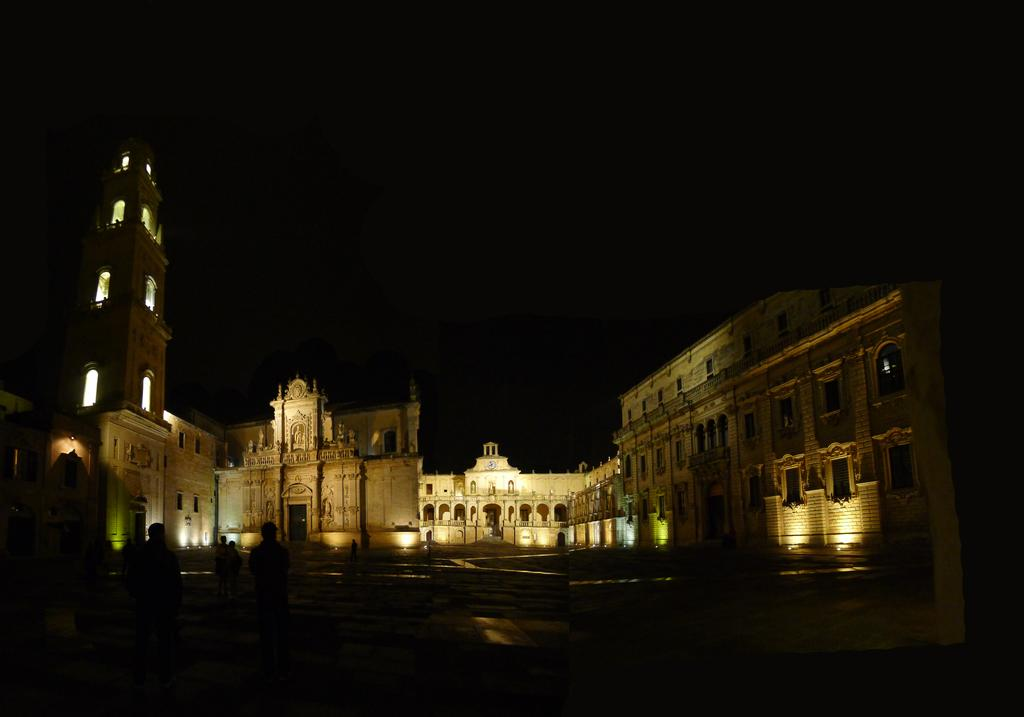What type of structures can be seen in the image? There are buildings in the image. Are there any living beings present in the image? Yes, there are people standing in the image. What can be seen illuminating the scene in the image? There are lights visible in the image. How would you describe the overall lighting in the image? The background of the image is dark. What type of shoe is being shaken by the slave in the image? There is no shoe or slave present in the image. 